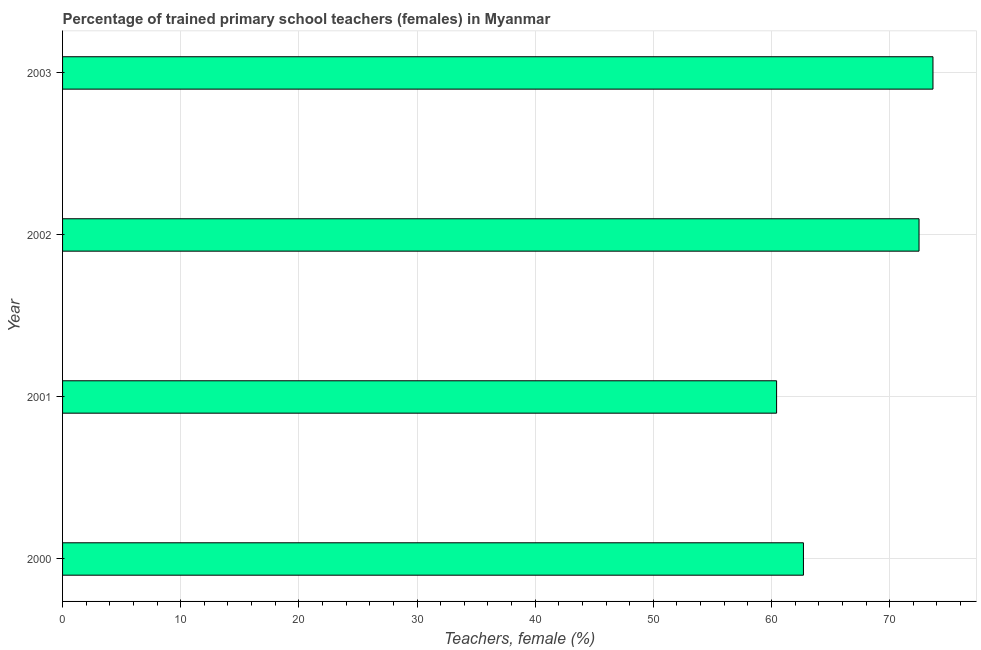What is the title of the graph?
Provide a succinct answer. Percentage of trained primary school teachers (females) in Myanmar. What is the label or title of the X-axis?
Offer a very short reply. Teachers, female (%). What is the percentage of trained female teachers in 2003?
Provide a succinct answer. 73.66. Across all years, what is the maximum percentage of trained female teachers?
Your answer should be very brief. 73.66. Across all years, what is the minimum percentage of trained female teachers?
Keep it short and to the point. 60.43. In which year was the percentage of trained female teachers maximum?
Provide a short and direct response. 2003. In which year was the percentage of trained female teachers minimum?
Offer a very short reply. 2001. What is the sum of the percentage of trained female teachers?
Ensure brevity in your answer.  269.28. What is the difference between the percentage of trained female teachers in 2000 and 2002?
Your response must be concise. -9.78. What is the average percentage of trained female teachers per year?
Offer a very short reply. 67.32. What is the median percentage of trained female teachers?
Your response must be concise. 67.59. In how many years, is the percentage of trained female teachers greater than 42 %?
Your answer should be very brief. 4. What is the ratio of the percentage of trained female teachers in 2001 to that in 2002?
Keep it short and to the point. 0.83. Is the percentage of trained female teachers in 2000 less than that in 2001?
Make the answer very short. No. What is the difference between the highest and the second highest percentage of trained female teachers?
Offer a terse response. 1.18. Is the sum of the percentage of trained female teachers in 2001 and 2002 greater than the maximum percentage of trained female teachers across all years?
Keep it short and to the point. Yes. What is the difference between the highest and the lowest percentage of trained female teachers?
Your response must be concise. 13.23. In how many years, is the percentage of trained female teachers greater than the average percentage of trained female teachers taken over all years?
Your response must be concise. 2. How many bars are there?
Ensure brevity in your answer.  4. Are the values on the major ticks of X-axis written in scientific E-notation?
Provide a short and direct response. No. What is the Teachers, female (%) of 2000?
Make the answer very short. 62.7. What is the Teachers, female (%) in 2001?
Your answer should be very brief. 60.43. What is the Teachers, female (%) in 2002?
Ensure brevity in your answer.  72.48. What is the Teachers, female (%) in 2003?
Provide a short and direct response. 73.66. What is the difference between the Teachers, female (%) in 2000 and 2001?
Offer a very short reply. 2.27. What is the difference between the Teachers, female (%) in 2000 and 2002?
Give a very brief answer. -9.78. What is the difference between the Teachers, female (%) in 2000 and 2003?
Give a very brief answer. -10.96. What is the difference between the Teachers, female (%) in 2001 and 2002?
Provide a succinct answer. -12.05. What is the difference between the Teachers, female (%) in 2001 and 2003?
Make the answer very short. -13.23. What is the difference between the Teachers, female (%) in 2002 and 2003?
Your answer should be compact. -1.18. What is the ratio of the Teachers, female (%) in 2000 to that in 2001?
Provide a short and direct response. 1.04. What is the ratio of the Teachers, female (%) in 2000 to that in 2002?
Ensure brevity in your answer.  0.86. What is the ratio of the Teachers, female (%) in 2000 to that in 2003?
Your answer should be very brief. 0.85. What is the ratio of the Teachers, female (%) in 2001 to that in 2002?
Ensure brevity in your answer.  0.83. What is the ratio of the Teachers, female (%) in 2001 to that in 2003?
Provide a succinct answer. 0.82. 